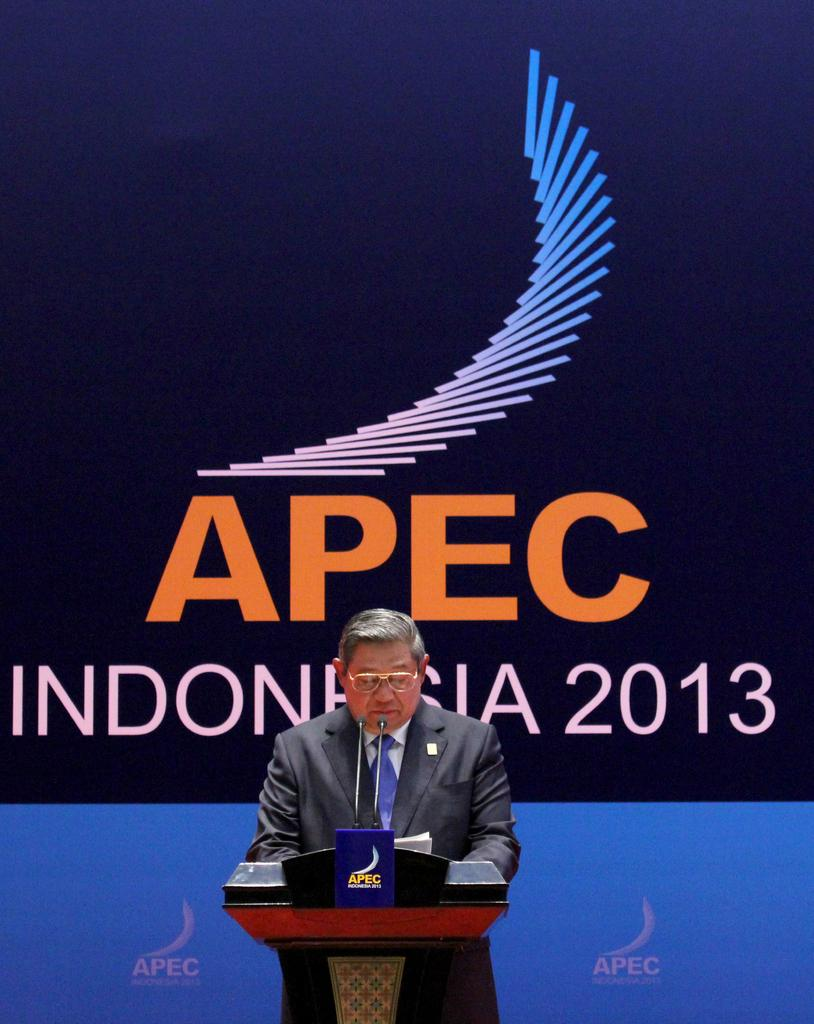<image>
Offer a succinct explanation of the picture presented. a man speaking at a microphone for an Apec 2013 conference 